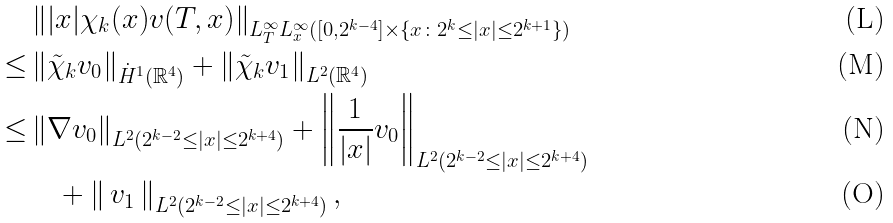<formula> <loc_0><loc_0><loc_500><loc_500>& \left \| | x | \chi _ { k } ( x ) v ( T , x ) \right \| _ { L _ { T } ^ { \infty } L _ { x } ^ { \infty } ( [ 0 , 2 ^ { k - 4 } ] \times \{ x \colon 2 ^ { k } \leq | x | \leq 2 ^ { k + 1 } \} ) } \\ \leq & \left \| \tilde { \chi } _ { k } v _ { 0 } \right \| _ { \dot { H } ^ { 1 } ( \mathbb { R } ^ { 4 } ) } + \left \| \tilde { \chi } _ { k } v _ { 1 } \right \| _ { L ^ { 2 } ( \mathbb { R } ^ { 4 } ) } \\ \leq & \left \| \nabla v _ { 0 } \right \| _ { L ^ { 2 } ( 2 ^ { k - 2 } \leq | x | \leq 2 ^ { k + 4 } ) } + \left \| \frac { 1 } { | x | } v _ { 0 } \right \| _ { L ^ { 2 } ( 2 ^ { k - 2 } \leq | x | \leq 2 ^ { k + 4 } ) } \\ & \quad + \left \| \, v _ { 1 } \, \right \| _ { L ^ { 2 } ( 2 ^ { k - 2 } \leq | x | \leq 2 ^ { k + 4 } ) } ,</formula> 